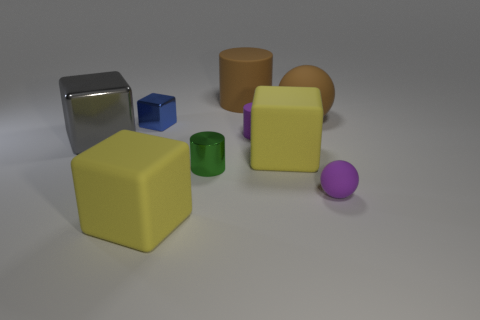Subtract 1 blocks. How many blocks are left? 3 Subtract all large blocks. How many blocks are left? 1 Subtract all gray blocks. How many blocks are left? 3 Subtract all red blocks. Subtract all red balls. How many blocks are left? 4 Subtract all spheres. How many objects are left? 7 Add 1 tiny blocks. How many objects exist? 10 Add 3 brown things. How many brown things exist? 5 Subtract 0 blue balls. How many objects are left? 9 Subtract all tiny green cylinders. Subtract all large brown metallic spheres. How many objects are left? 8 Add 3 big rubber things. How many big rubber things are left? 7 